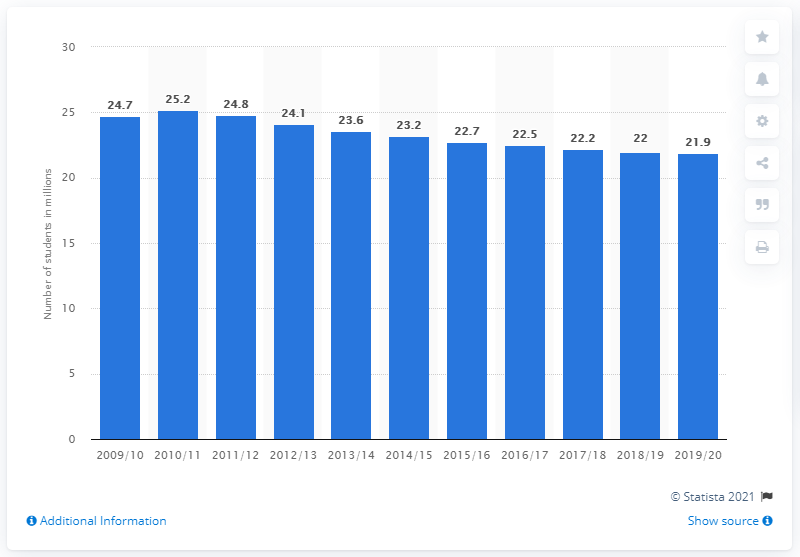Highlight a few significant elements in this photo. The last academic year of the U.S. Census was in the academic year 2009/2010. In the academic year 2019/2020, a total of 21.9 students enrolled for undergraduate degrees in the United States. 